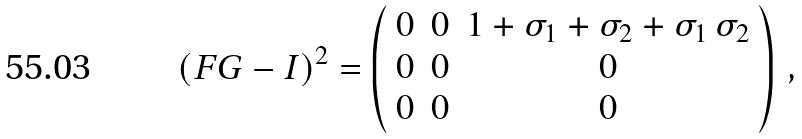Convert formula to latex. <formula><loc_0><loc_0><loc_500><loc_500>( F G - I ) ^ { 2 } = \left ( \begin{array} { c c c } 0 & 0 & 1 + \sigma _ { 1 } + \sigma _ { 2 } + \sigma _ { 1 } \, \sigma _ { 2 } \\ 0 & 0 & 0 \\ 0 & 0 & 0 \\ \end{array} \right ) \, ,</formula> 